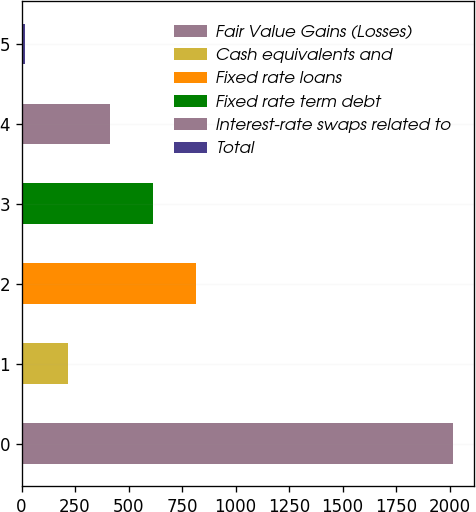Convert chart. <chart><loc_0><loc_0><loc_500><loc_500><bar_chart><fcel>Fair Value Gains (Losses)<fcel>Cash equivalents and<fcel>Fixed rate loans<fcel>Fixed rate term debt<fcel>Interest-rate swaps related to<fcel>Total<nl><fcel>2014<fcel>214.99<fcel>814.66<fcel>614.77<fcel>414.88<fcel>15.1<nl></chart> 